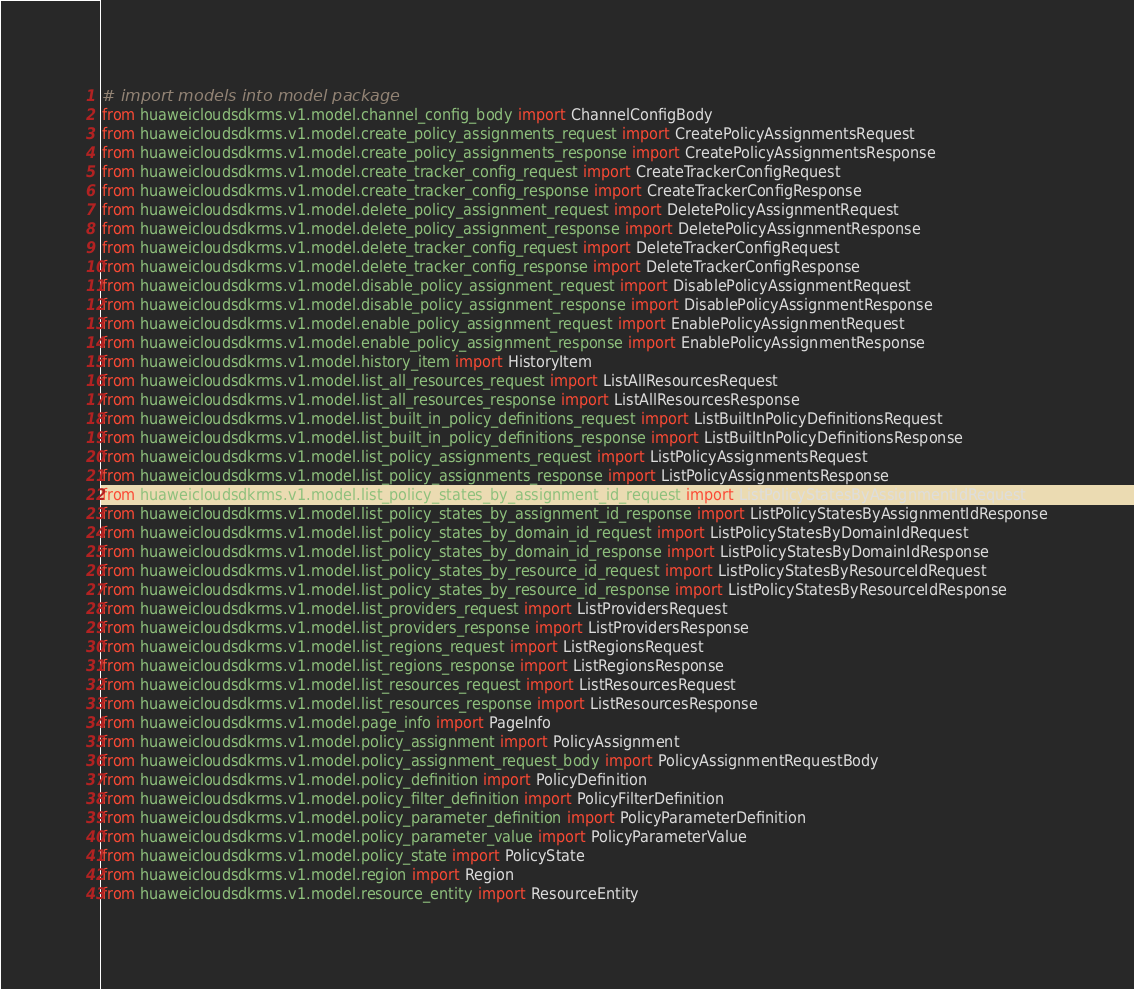Convert code to text. <code><loc_0><loc_0><loc_500><loc_500><_Python_>
# import models into model package
from huaweicloudsdkrms.v1.model.channel_config_body import ChannelConfigBody
from huaweicloudsdkrms.v1.model.create_policy_assignments_request import CreatePolicyAssignmentsRequest
from huaweicloudsdkrms.v1.model.create_policy_assignments_response import CreatePolicyAssignmentsResponse
from huaweicloudsdkrms.v1.model.create_tracker_config_request import CreateTrackerConfigRequest
from huaweicloudsdkrms.v1.model.create_tracker_config_response import CreateTrackerConfigResponse
from huaweicloudsdkrms.v1.model.delete_policy_assignment_request import DeletePolicyAssignmentRequest
from huaweicloudsdkrms.v1.model.delete_policy_assignment_response import DeletePolicyAssignmentResponse
from huaweicloudsdkrms.v1.model.delete_tracker_config_request import DeleteTrackerConfigRequest
from huaweicloudsdkrms.v1.model.delete_tracker_config_response import DeleteTrackerConfigResponse
from huaweicloudsdkrms.v1.model.disable_policy_assignment_request import DisablePolicyAssignmentRequest
from huaweicloudsdkrms.v1.model.disable_policy_assignment_response import DisablePolicyAssignmentResponse
from huaweicloudsdkrms.v1.model.enable_policy_assignment_request import EnablePolicyAssignmentRequest
from huaweicloudsdkrms.v1.model.enable_policy_assignment_response import EnablePolicyAssignmentResponse
from huaweicloudsdkrms.v1.model.history_item import HistoryItem
from huaweicloudsdkrms.v1.model.list_all_resources_request import ListAllResourcesRequest
from huaweicloudsdkrms.v1.model.list_all_resources_response import ListAllResourcesResponse
from huaweicloudsdkrms.v1.model.list_built_in_policy_definitions_request import ListBuiltInPolicyDefinitionsRequest
from huaweicloudsdkrms.v1.model.list_built_in_policy_definitions_response import ListBuiltInPolicyDefinitionsResponse
from huaweicloudsdkrms.v1.model.list_policy_assignments_request import ListPolicyAssignmentsRequest
from huaweicloudsdkrms.v1.model.list_policy_assignments_response import ListPolicyAssignmentsResponse
from huaweicloudsdkrms.v1.model.list_policy_states_by_assignment_id_request import ListPolicyStatesByAssignmentIdRequest
from huaweicloudsdkrms.v1.model.list_policy_states_by_assignment_id_response import ListPolicyStatesByAssignmentIdResponse
from huaweicloudsdkrms.v1.model.list_policy_states_by_domain_id_request import ListPolicyStatesByDomainIdRequest
from huaweicloudsdkrms.v1.model.list_policy_states_by_domain_id_response import ListPolicyStatesByDomainIdResponse
from huaweicloudsdkrms.v1.model.list_policy_states_by_resource_id_request import ListPolicyStatesByResourceIdRequest
from huaweicloudsdkrms.v1.model.list_policy_states_by_resource_id_response import ListPolicyStatesByResourceIdResponse
from huaweicloudsdkrms.v1.model.list_providers_request import ListProvidersRequest
from huaweicloudsdkrms.v1.model.list_providers_response import ListProvidersResponse
from huaweicloudsdkrms.v1.model.list_regions_request import ListRegionsRequest
from huaweicloudsdkrms.v1.model.list_regions_response import ListRegionsResponse
from huaweicloudsdkrms.v1.model.list_resources_request import ListResourcesRequest
from huaweicloudsdkrms.v1.model.list_resources_response import ListResourcesResponse
from huaweicloudsdkrms.v1.model.page_info import PageInfo
from huaweicloudsdkrms.v1.model.policy_assignment import PolicyAssignment
from huaweicloudsdkrms.v1.model.policy_assignment_request_body import PolicyAssignmentRequestBody
from huaweicloudsdkrms.v1.model.policy_definition import PolicyDefinition
from huaweicloudsdkrms.v1.model.policy_filter_definition import PolicyFilterDefinition
from huaweicloudsdkrms.v1.model.policy_parameter_definition import PolicyParameterDefinition
from huaweicloudsdkrms.v1.model.policy_parameter_value import PolicyParameterValue
from huaweicloudsdkrms.v1.model.policy_state import PolicyState
from huaweicloudsdkrms.v1.model.region import Region
from huaweicloudsdkrms.v1.model.resource_entity import ResourceEntity</code> 